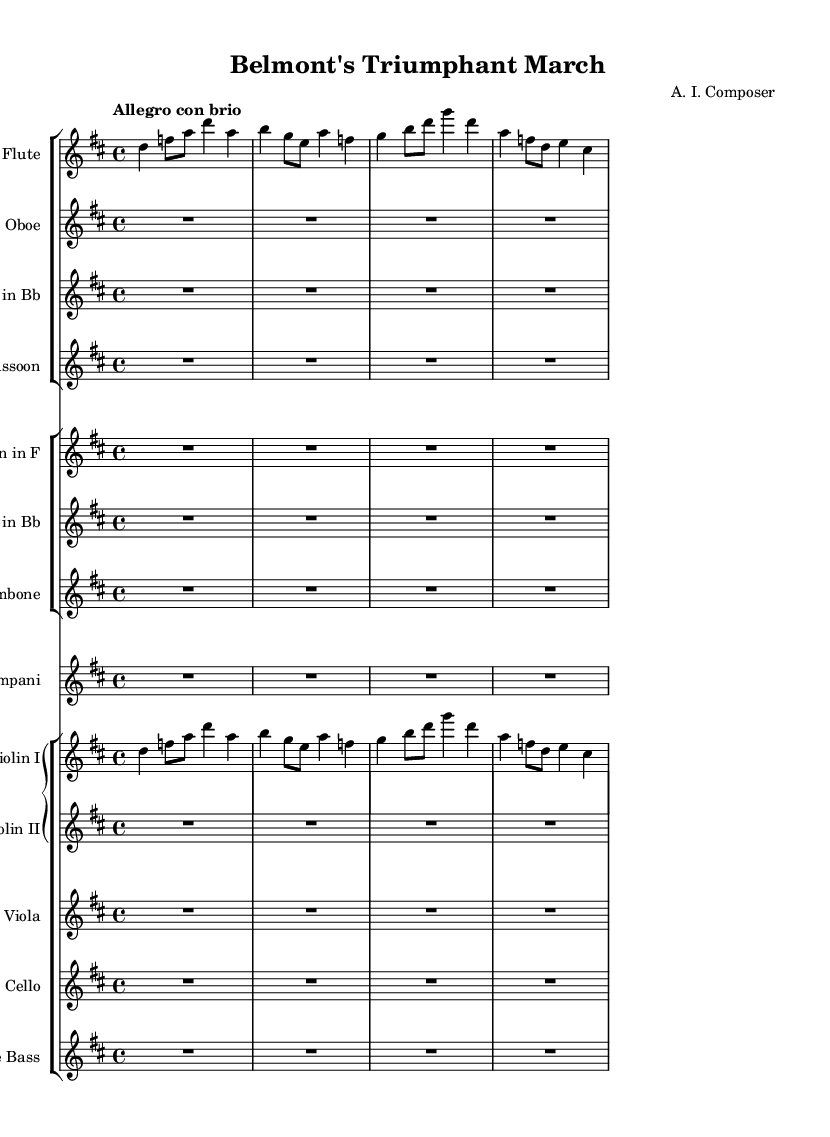What is the key signature of this music? The key signature shows two sharps, which indicates the music is in D major.
Answer: D major What is the time signature of this music? The time signature is indicated at the beginning of the score, showing a 4/4 pattern, meaning there are four beats in each measure.
Answer: 4/4 What is the tempo marking of this piece? The tempo marking at the start indicates "Allegro con brio," which suggests a fast and lively pace.
Answer: Allegro con brio Which instruments are playing the melody in the first section? The flute and Violin I are both playing the prominent melodic lines in the first section of the score.
Answer: Flute, Violin I How many measures does the flute part contain in the given excerpt? The flute part shows a total of 4 measures with corresponding notes, as indicated by the bar lines separating the music.
Answer: 4 What instruments are silent for the entire excerpt? The parts for oboe, clarinet, bassoon, horn, trumpet, trombone, timpani, violin II, viola, cello, and double bass show rests for the full duration, indicating silence.
Answer: Oboe, Clarinet, Bassoon, Horn, Trumpet, Trombone, Timpani, Violin II, Viola, Cello, Double Bass What role does the timpani play in this piece? The timpani part is marked as a rest throughout the excerpt, indicating it does not play in this section.
Answer: Rest 